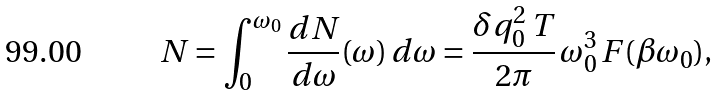Convert formula to latex. <formula><loc_0><loc_0><loc_500><loc_500>N = \int _ { 0 } ^ { \omega _ { 0 } } \frac { d N } { d \omega } ( \omega ) \, d \omega = \frac { \delta q _ { 0 } ^ { 2 } \, T } { 2 \pi } \, \omega _ { 0 } ^ { 3 } \, F ( \beta \omega _ { 0 } ) ,</formula> 